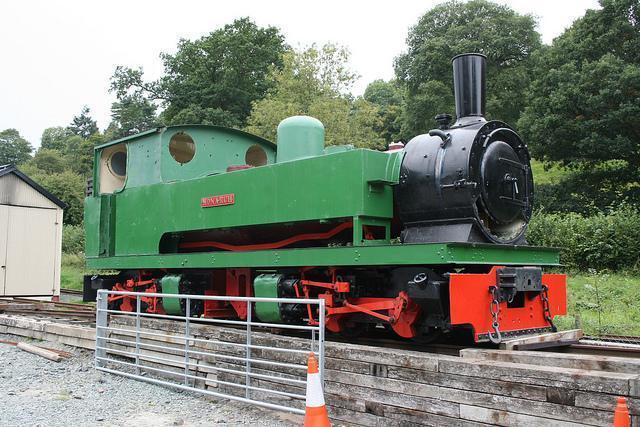How many safety cones are in the photo?
Give a very brief answer. 2. How many cars does this train have?
Give a very brief answer. 1. How many flags are on the train?
Give a very brief answer. 0. 